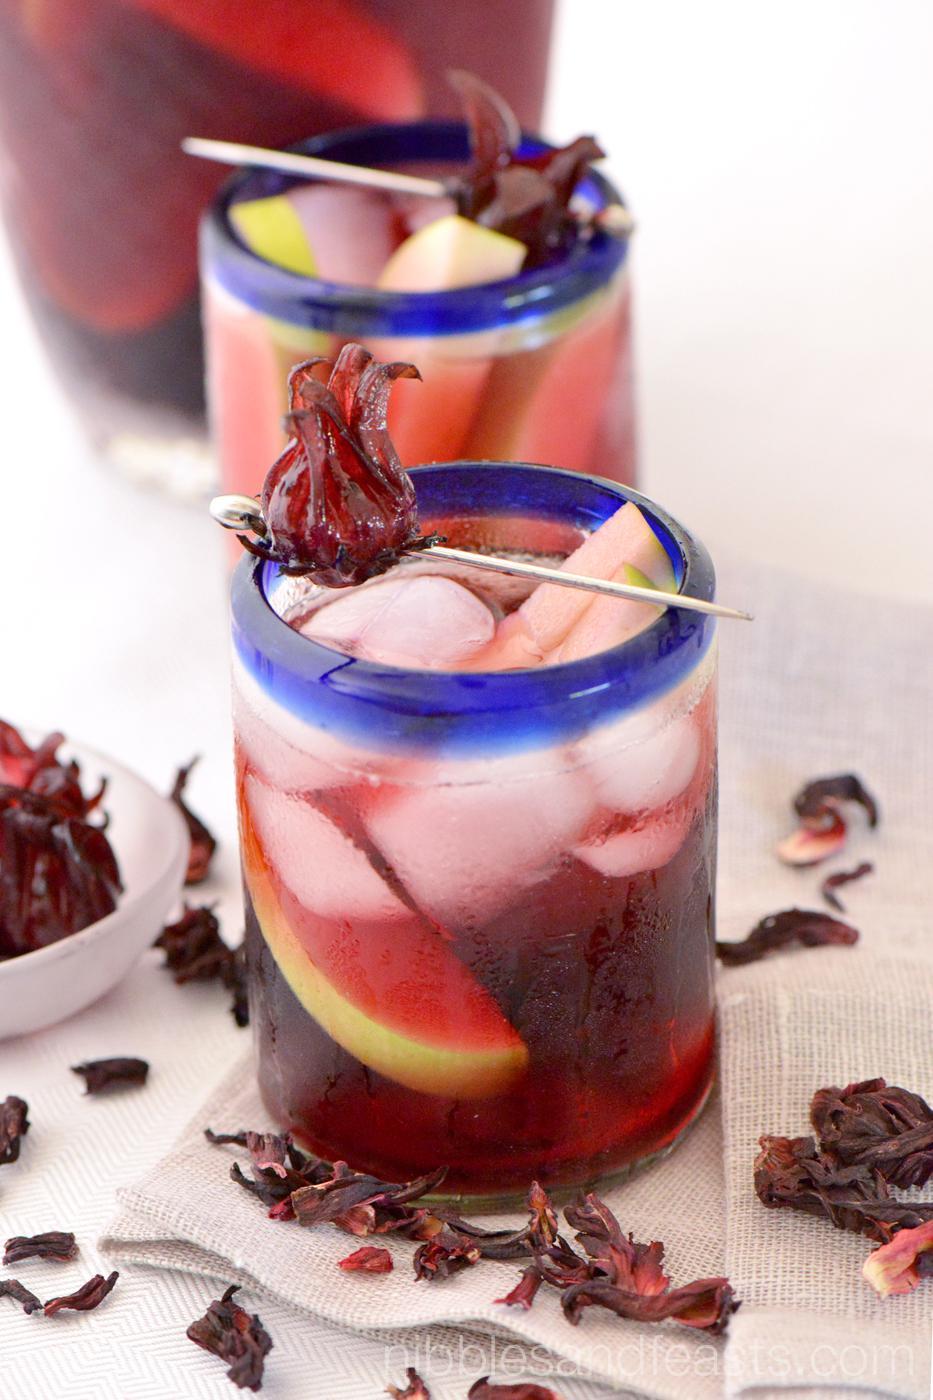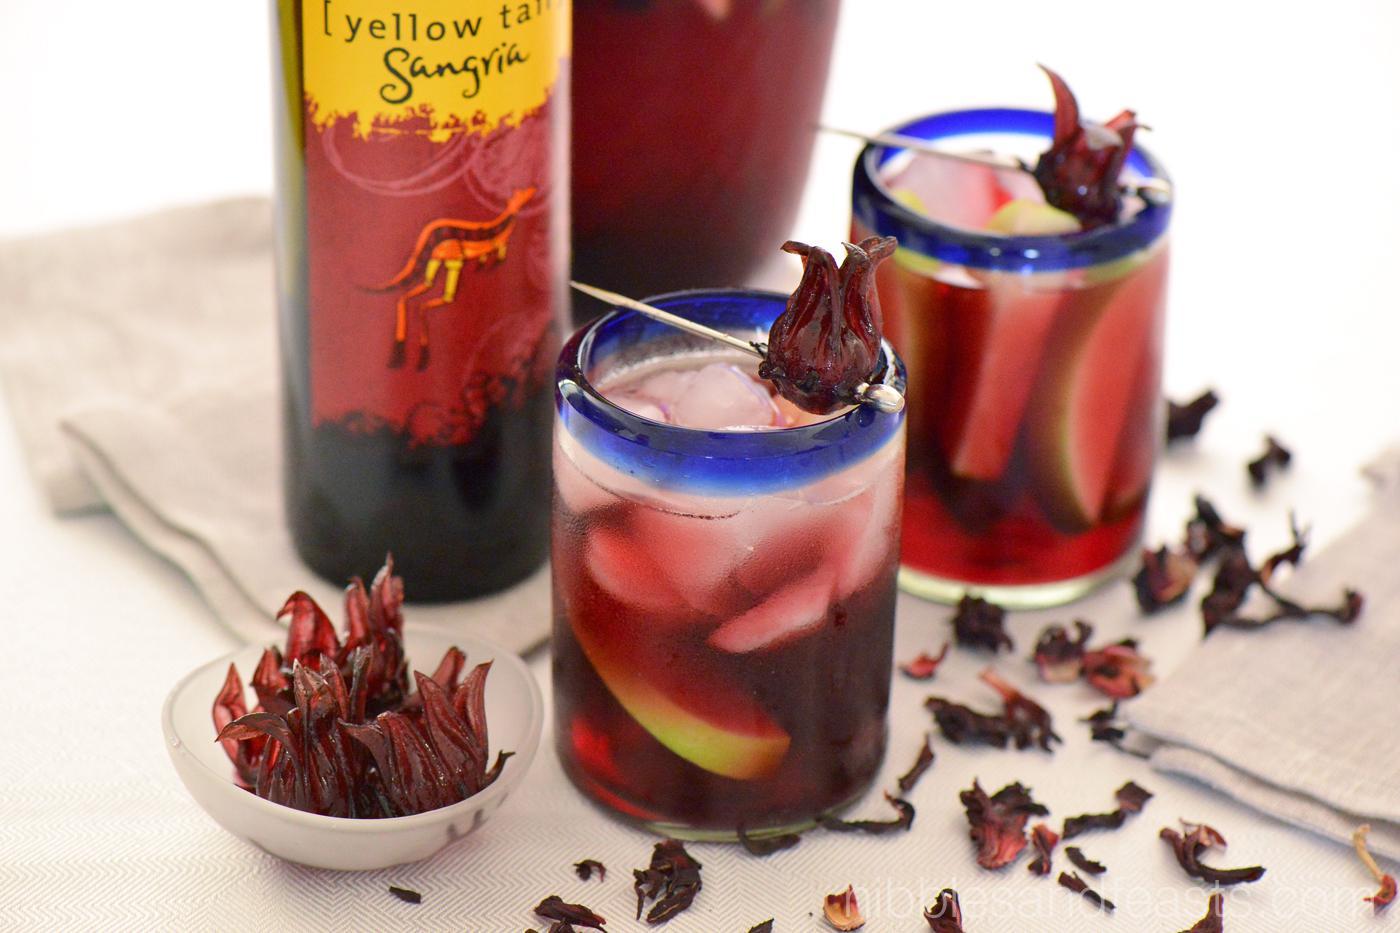The first image is the image on the left, the second image is the image on the right. Analyze the images presented: Is the assertion "At least one image shows a beverage with a lime wedge as its garnish." valid? Answer yes or no. No. The first image is the image on the left, the second image is the image on the right. Assess this claim about the two images: "Lime is used as a garnish in at least one image.". Correct or not? Answer yes or no. No. 